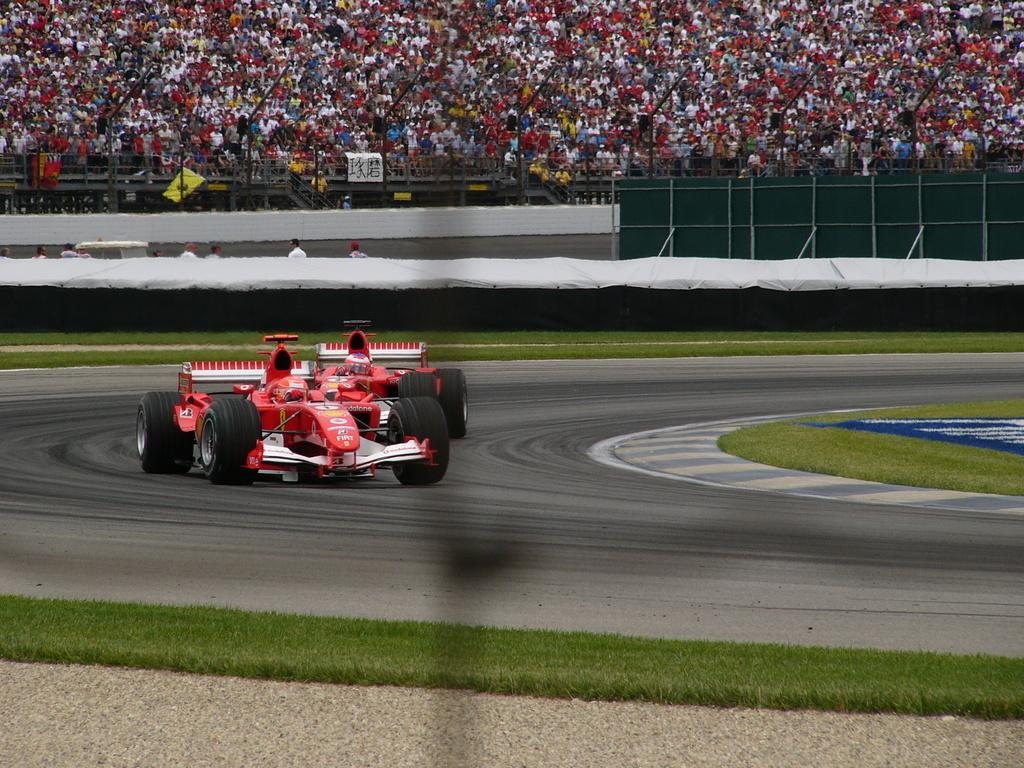What can be seen on the road in the image? There are vehicles on the road in the image. What type of vegetation is visible on the ground in the image? Grass is visible on the ground in the image. What type of barrier is present in the image? There is fencing in the image. What type of writing surface is present in the image? A whiteboard is present in the image. How many people can be seen in the background of the image? Many people are visible in the background of the image. How does the journey of the leaves fall in the image? There are no leaves or journey of leaves present in the image. What process is being used to create the whiteboard in the image? The whiteboard is a stationary object in the image and does not involve any process. 